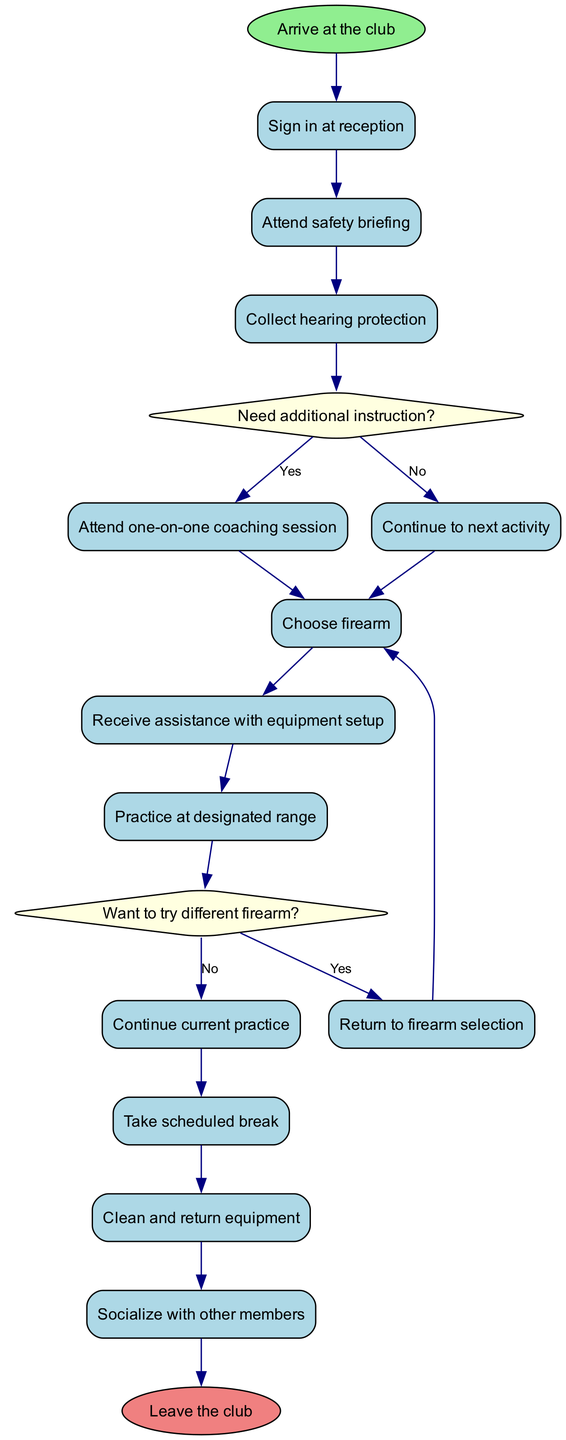What is the initial activity in the diagram? The diagram shows "Arrive at the club" as the starting point or initial activity.
Answer: Arrive at the club How many activities are listed in the diagram? By counting the activities shown, there are a total of eight distinct activities mentioned.
Answer: 8 What are the options after "Collect hearing protection"? The diagram indicates a decision point following this activity, leading to two options: "Need additional instruction?" which branches into "Attend one-on-one coaching session" or "Continue to next activity".
Answer: Attend one-on-one coaching session or Continue to next activity What activity immediately follows "Choose firearm"? After "Choose firearm", the flow according to the diagram proceeds to "Receive assistance with equipment setup".
Answer: Receive assistance with equipment setup If a member wants to try a different firearm, what will they return to? If a member decides to try a different firearm, they would return to the "Choose firearm" activity, as indicated in the decision flow for that option.
Answer: Choose firearm What happens if a member answers "No" to the question about needing additional instruction? Choosing "No" leads the member to "Continue to next activity", which directly follows this decision, allowing them to move forward in the sequence.
Answer: Continue to next activity How does the diagram end? The sequence of activities concludes with the final node labeled "Leave the club", which signifies the end of the activities.
Answer: Leave the club What decision occurs after "Practice at designated range"? The decision made after "Practice at designated range" is "Want to try different firearm?", indicating a choice that affects the next steps.
Answer: Want to try different firearm? What color is used for the final node in the diagram? The final node "Leave the club" has a fill color of light coral, recognizable within the color coding of the diagram.
Answer: Light coral 